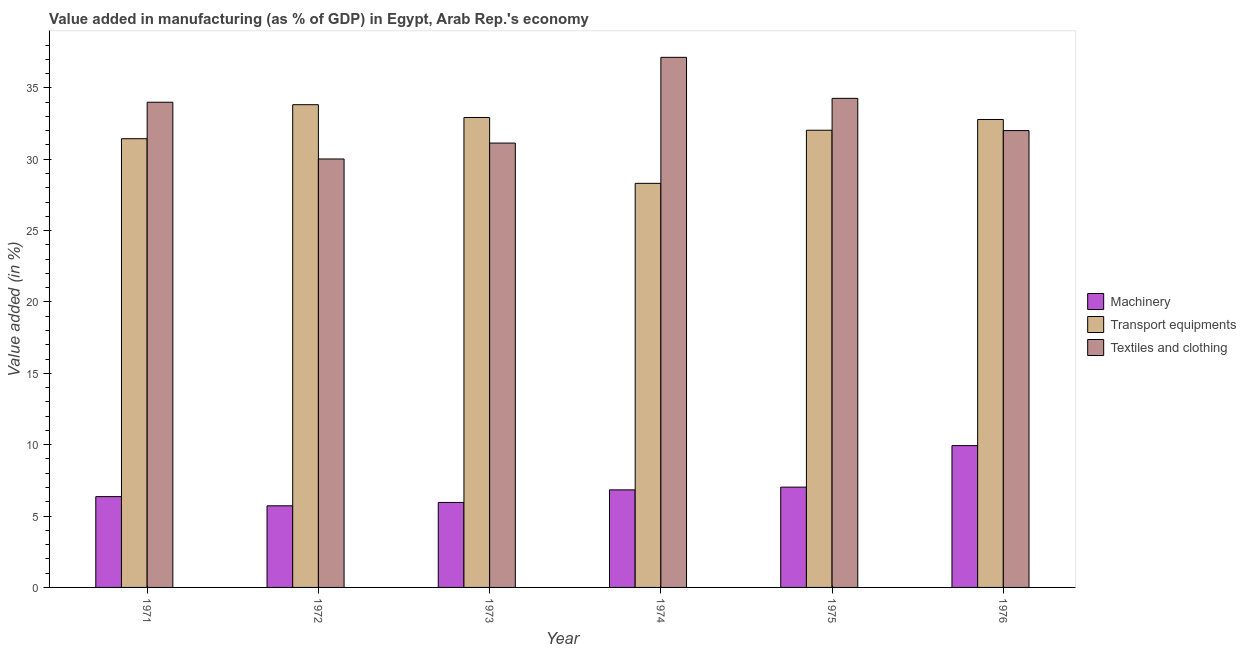How many groups of bars are there?
Offer a terse response. 6. Are the number of bars per tick equal to the number of legend labels?
Your answer should be very brief. Yes. How many bars are there on the 6th tick from the left?
Your answer should be very brief. 3. How many bars are there on the 5th tick from the right?
Provide a succinct answer. 3. What is the label of the 4th group of bars from the left?
Keep it short and to the point. 1974. In how many cases, is the number of bars for a given year not equal to the number of legend labels?
Keep it short and to the point. 0. What is the value added in manufacturing textile and clothing in 1976?
Your answer should be very brief. 32.01. Across all years, what is the maximum value added in manufacturing transport equipments?
Provide a short and direct response. 33.82. Across all years, what is the minimum value added in manufacturing machinery?
Your response must be concise. 5.72. In which year was the value added in manufacturing machinery maximum?
Your response must be concise. 1976. What is the total value added in manufacturing transport equipments in the graph?
Your response must be concise. 191.31. What is the difference between the value added in manufacturing transport equipments in 1971 and that in 1973?
Your answer should be very brief. -1.49. What is the difference between the value added in manufacturing textile and clothing in 1973 and the value added in manufacturing machinery in 1974?
Offer a very short reply. -6.01. What is the average value added in manufacturing textile and clothing per year?
Provide a short and direct response. 33.09. In the year 1974, what is the difference between the value added in manufacturing machinery and value added in manufacturing transport equipments?
Provide a succinct answer. 0. In how many years, is the value added in manufacturing machinery greater than 15 %?
Your answer should be compact. 0. What is the ratio of the value added in manufacturing machinery in 1971 to that in 1972?
Ensure brevity in your answer.  1.11. What is the difference between the highest and the second highest value added in manufacturing machinery?
Ensure brevity in your answer.  2.91. What is the difference between the highest and the lowest value added in manufacturing textile and clothing?
Your answer should be compact. 7.12. What does the 3rd bar from the left in 1971 represents?
Ensure brevity in your answer.  Textiles and clothing. What does the 2nd bar from the right in 1975 represents?
Offer a terse response. Transport equipments. Is it the case that in every year, the sum of the value added in manufacturing machinery and value added in manufacturing transport equipments is greater than the value added in manufacturing textile and clothing?
Your answer should be very brief. No. Are all the bars in the graph horizontal?
Provide a short and direct response. No. What is the difference between two consecutive major ticks on the Y-axis?
Provide a succinct answer. 5. Are the values on the major ticks of Y-axis written in scientific E-notation?
Your answer should be compact. No. Does the graph contain grids?
Your response must be concise. No. Where does the legend appear in the graph?
Offer a very short reply. Center right. How many legend labels are there?
Your answer should be very brief. 3. How are the legend labels stacked?
Give a very brief answer. Vertical. What is the title of the graph?
Your answer should be compact. Value added in manufacturing (as % of GDP) in Egypt, Arab Rep.'s economy. What is the label or title of the X-axis?
Your response must be concise. Year. What is the label or title of the Y-axis?
Offer a terse response. Value added (in %). What is the Value added (in %) in Machinery in 1971?
Provide a short and direct response. 6.36. What is the Value added (in %) in Transport equipments in 1971?
Ensure brevity in your answer.  31.44. What is the Value added (in %) in Textiles and clothing in 1971?
Provide a short and direct response. 33.99. What is the Value added (in %) in Machinery in 1972?
Your answer should be compact. 5.72. What is the Value added (in %) in Transport equipments in 1972?
Keep it short and to the point. 33.82. What is the Value added (in %) of Textiles and clothing in 1972?
Give a very brief answer. 30.02. What is the Value added (in %) of Machinery in 1973?
Keep it short and to the point. 5.95. What is the Value added (in %) in Transport equipments in 1973?
Offer a very short reply. 32.92. What is the Value added (in %) of Textiles and clothing in 1973?
Keep it short and to the point. 31.13. What is the Value added (in %) of Machinery in 1974?
Keep it short and to the point. 6.83. What is the Value added (in %) of Transport equipments in 1974?
Your answer should be very brief. 28.31. What is the Value added (in %) of Textiles and clothing in 1974?
Keep it short and to the point. 37.14. What is the Value added (in %) in Machinery in 1975?
Ensure brevity in your answer.  7.03. What is the Value added (in %) of Transport equipments in 1975?
Keep it short and to the point. 32.03. What is the Value added (in %) of Textiles and clothing in 1975?
Provide a succinct answer. 34.27. What is the Value added (in %) of Machinery in 1976?
Your response must be concise. 9.94. What is the Value added (in %) of Transport equipments in 1976?
Ensure brevity in your answer.  32.79. What is the Value added (in %) of Textiles and clothing in 1976?
Keep it short and to the point. 32.01. Across all years, what is the maximum Value added (in %) of Machinery?
Ensure brevity in your answer.  9.94. Across all years, what is the maximum Value added (in %) in Transport equipments?
Your answer should be very brief. 33.82. Across all years, what is the maximum Value added (in %) of Textiles and clothing?
Give a very brief answer. 37.14. Across all years, what is the minimum Value added (in %) of Machinery?
Your answer should be very brief. 5.72. Across all years, what is the minimum Value added (in %) in Transport equipments?
Provide a succinct answer. 28.31. Across all years, what is the minimum Value added (in %) in Textiles and clothing?
Ensure brevity in your answer.  30.02. What is the total Value added (in %) of Machinery in the graph?
Keep it short and to the point. 41.83. What is the total Value added (in %) of Transport equipments in the graph?
Offer a very short reply. 191.31. What is the total Value added (in %) of Textiles and clothing in the graph?
Provide a short and direct response. 198.56. What is the difference between the Value added (in %) in Machinery in 1971 and that in 1972?
Offer a very short reply. 0.64. What is the difference between the Value added (in %) of Transport equipments in 1971 and that in 1972?
Ensure brevity in your answer.  -2.38. What is the difference between the Value added (in %) in Textiles and clothing in 1971 and that in 1972?
Make the answer very short. 3.98. What is the difference between the Value added (in %) of Machinery in 1971 and that in 1973?
Your response must be concise. 0.41. What is the difference between the Value added (in %) in Transport equipments in 1971 and that in 1973?
Offer a terse response. -1.49. What is the difference between the Value added (in %) of Textiles and clothing in 1971 and that in 1973?
Offer a terse response. 2.86. What is the difference between the Value added (in %) in Machinery in 1971 and that in 1974?
Offer a terse response. -0.47. What is the difference between the Value added (in %) of Transport equipments in 1971 and that in 1974?
Offer a very short reply. 3.13. What is the difference between the Value added (in %) of Textiles and clothing in 1971 and that in 1974?
Your answer should be compact. -3.15. What is the difference between the Value added (in %) in Machinery in 1971 and that in 1975?
Offer a terse response. -0.66. What is the difference between the Value added (in %) in Transport equipments in 1971 and that in 1975?
Make the answer very short. -0.59. What is the difference between the Value added (in %) in Textiles and clothing in 1971 and that in 1975?
Provide a short and direct response. -0.27. What is the difference between the Value added (in %) of Machinery in 1971 and that in 1976?
Your answer should be very brief. -3.57. What is the difference between the Value added (in %) of Transport equipments in 1971 and that in 1976?
Your response must be concise. -1.35. What is the difference between the Value added (in %) of Textiles and clothing in 1971 and that in 1976?
Provide a short and direct response. 1.99. What is the difference between the Value added (in %) of Machinery in 1972 and that in 1973?
Offer a terse response. -0.24. What is the difference between the Value added (in %) in Transport equipments in 1972 and that in 1973?
Give a very brief answer. 0.9. What is the difference between the Value added (in %) in Textiles and clothing in 1972 and that in 1973?
Give a very brief answer. -1.11. What is the difference between the Value added (in %) of Machinery in 1972 and that in 1974?
Your answer should be compact. -1.12. What is the difference between the Value added (in %) of Transport equipments in 1972 and that in 1974?
Your answer should be very brief. 5.51. What is the difference between the Value added (in %) in Textiles and clothing in 1972 and that in 1974?
Keep it short and to the point. -7.12. What is the difference between the Value added (in %) in Machinery in 1972 and that in 1975?
Your answer should be very brief. -1.31. What is the difference between the Value added (in %) in Transport equipments in 1972 and that in 1975?
Provide a short and direct response. 1.79. What is the difference between the Value added (in %) in Textiles and clothing in 1972 and that in 1975?
Provide a succinct answer. -4.25. What is the difference between the Value added (in %) in Machinery in 1972 and that in 1976?
Give a very brief answer. -4.22. What is the difference between the Value added (in %) of Transport equipments in 1972 and that in 1976?
Ensure brevity in your answer.  1.04. What is the difference between the Value added (in %) of Textiles and clothing in 1972 and that in 1976?
Offer a very short reply. -1.99. What is the difference between the Value added (in %) of Machinery in 1973 and that in 1974?
Offer a very short reply. -0.88. What is the difference between the Value added (in %) of Transport equipments in 1973 and that in 1974?
Provide a short and direct response. 4.61. What is the difference between the Value added (in %) in Textiles and clothing in 1973 and that in 1974?
Offer a very short reply. -6.01. What is the difference between the Value added (in %) of Machinery in 1973 and that in 1975?
Keep it short and to the point. -1.07. What is the difference between the Value added (in %) in Transport equipments in 1973 and that in 1975?
Your response must be concise. 0.89. What is the difference between the Value added (in %) of Textiles and clothing in 1973 and that in 1975?
Keep it short and to the point. -3.13. What is the difference between the Value added (in %) in Machinery in 1973 and that in 1976?
Your answer should be very brief. -3.98. What is the difference between the Value added (in %) of Transport equipments in 1973 and that in 1976?
Keep it short and to the point. 0.14. What is the difference between the Value added (in %) of Textiles and clothing in 1973 and that in 1976?
Provide a succinct answer. -0.88. What is the difference between the Value added (in %) of Machinery in 1974 and that in 1975?
Your answer should be very brief. -0.19. What is the difference between the Value added (in %) in Transport equipments in 1974 and that in 1975?
Your response must be concise. -3.72. What is the difference between the Value added (in %) of Textiles and clothing in 1974 and that in 1975?
Your answer should be very brief. 2.87. What is the difference between the Value added (in %) in Machinery in 1974 and that in 1976?
Your response must be concise. -3.1. What is the difference between the Value added (in %) of Transport equipments in 1974 and that in 1976?
Provide a short and direct response. -4.47. What is the difference between the Value added (in %) of Textiles and clothing in 1974 and that in 1976?
Offer a terse response. 5.13. What is the difference between the Value added (in %) in Machinery in 1975 and that in 1976?
Provide a short and direct response. -2.91. What is the difference between the Value added (in %) of Transport equipments in 1975 and that in 1976?
Your answer should be compact. -0.75. What is the difference between the Value added (in %) in Textiles and clothing in 1975 and that in 1976?
Your answer should be very brief. 2.26. What is the difference between the Value added (in %) of Machinery in 1971 and the Value added (in %) of Transport equipments in 1972?
Give a very brief answer. -27.46. What is the difference between the Value added (in %) in Machinery in 1971 and the Value added (in %) in Textiles and clothing in 1972?
Provide a short and direct response. -23.66. What is the difference between the Value added (in %) in Transport equipments in 1971 and the Value added (in %) in Textiles and clothing in 1972?
Provide a short and direct response. 1.42. What is the difference between the Value added (in %) of Machinery in 1971 and the Value added (in %) of Transport equipments in 1973?
Make the answer very short. -26.56. What is the difference between the Value added (in %) in Machinery in 1971 and the Value added (in %) in Textiles and clothing in 1973?
Your answer should be very brief. -24.77. What is the difference between the Value added (in %) of Transport equipments in 1971 and the Value added (in %) of Textiles and clothing in 1973?
Provide a succinct answer. 0.31. What is the difference between the Value added (in %) of Machinery in 1971 and the Value added (in %) of Transport equipments in 1974?
Your answer should be compact. -21.95. What is the difference between the Value added (in %) in Machinery in 1971 and the Value added (in %) in Textiles and clothing in 1974?
Provide a succinct answer. -30.78. What is the difference between the Value added (in %) in Transport equipments in 1971 and the Value added (in %) in Textiles and clothing in 1974?
Give a very brief answer. -5.7. What is the difference between the Value added (in %) of Machinery in 1971 and the Value added (in %) of Transport equipments in 1975?
Provide a succinct answer. -25.67. What is the difference between the Value added (in %) of Machinery in 1971 and the Value added (in %) of Textiles and clothing in 1975?
Offer a very short reply. -27.9. What is the difference between the Value added (in %) in Transport equipments in 1971 and the Value added (in %) in Textiles and clothing in 1975?
Give a very brief answer. -2.83. What is the difference between the Value added (in %) of Machinery in 1971 and the Value added (in %) of Transport equipments in 1976?
Keep it short and to the point. -26.42. What is the difference between the Value added (in %) in Machinery in 1971 and the Value added (in %) in Textiles and clothing in 1976?
Keep it short and to the point. -25.65. What is the difference between the Value added (in %) of Transport equipments in 1971 and the Value added (in %) of Textiles and clothing in 1976?
Your answer should be compact. -0.57. What is the difference between the Value added (in %) of Machinery in 1972 and the Value added (in %) of Transport equipments in 1973?
Provide a short and direct response. -27.21. What is the difference between the Value added (in %) of Machinery in 1972 and the Value added (in %) of Textiles and clothing in 1973?
Your response must be concise. -25.41. What is the difference between the Value added (in %) in Transport equipments in 1972 and the Value added (in %) in Textiles and clothing in 1973?
Your answer should be compact. 2.69. What is the difference between the Value added (in %) of Machinery in 1972 and the Value added (in %) of Transport equipments in 1974?
Your response must be concise. -22.59. What is the difference between the Value added (in %) in Machinery in 1972 and the Value added (in %) in Textiles and clothing in 1974?
Your answer should be compact. -31.42. What is the difference between the Value added (in %) in Transport equipments in 1972 and the Value added (in %) in Textiles and clothing in 1974?
Ensure brevity in your answer.  -3.32. What is the difference between the Value added (in %) in Machinery in 1972 and the Value added (in %) in Transport equipments in 1975?
Offer a terse response. -26.31. What is the difference between the Value added (in %) of Machinery in 1972 and the Value added (in %) of Textiles and clothing in 1975?
Give a very brief answer. -28.55. What is the difference between the Value added (in %) of Transport equipments in 1972 and the Value added (in %) of Textiles and clothing in 1975?
Ensure brevity in your answer.  -0.44. What is the difference between the Value added (in %) of Machinery in 1972 and the Value added (in %) of Transport equipments in 1976?
Provide a succinct answer. -27.07. What is the difference between the Value added (in %) in Machinery in 1972 and the Value added (in %) in Textiles and clothing in 1976?
Your answer should be very brief. -26.29. What is the difference between the Value added (in %) of Transport equipments in 1972 and the Value added (in %) of Textiles and clothing in 1976?
Keep it short and to the point. 1.81. What is the difference between the Value added (in %) of Machinery in 1973 and the Value added (in %) of Transport equipments in 1974?
Offer a terse response. -22.36. What is the difference between the Value added (in %) of Machinery in 1973 and the Value added (in %) of Textiles and clothing in 1974?
Offer a terse response. -31.19. What is the difference between the Value added (in %) in Transport equipments in 1973 and the Value added (in %) in Textiles and clothing in 1974?
Provide a short and direct response. -4.22. What is the difference between the Value added (in %) of Machinery in 1973 and the Value added (in %) of Transport equipments in 1975?
Give a very brief answer. -26.08. What is the difference between the Value added (in %) of Machinery in 1973 and the Value added (in %) of Textiles and clothing in 1975?
Ensure brevity in your answer.  -28.31. What is the difference between the Value added (in %) in Transport equipments in 1973 and the Value added (in %) in Textiles and clothing in 1975?
Your answer should be compact. -1.34. What is the difference between the Value added (in %) of Machinery in 1973 and the Value added (in %) of Transport equipments in 1976?
Your answer should be compact. -26.83. What is the difference between the Value added (in %) in Machinery in 1973 and the Value added (in %) in Textiles and clothing in 1976?
Your response must be concise. -26.05. What is the difference between the Value added (in %) of Transport equipments in 1973 and the Value added (in %) of Textiles and clothing in 1976?
Provide a succinct answer. 0.92. What is the difference between the Value added (in %) of Machinery in 1974 and the Value added (in %) of Transport equipments in 1975?
Make the answer very short. -25.2. What is the difference between the Value added (in %) in Machinery in 1974 and the Value added (in %) in Textiles and clothing in 1975?
Provide a succinct answer. -27.43. What is the difference between the Value added (in %) in Transport equipments in 1974 and the Value added (in %) in Textiles and clothing in 1975?
Your answer should be very brief. -5.95. What is the difference between the Value added (in %) in Machinery in 1974 and the Value added (in %) in Transport equipments in 1976?
Offer a very short reply. -25.95. What is the difference between the Value added (in %) of Machinery in 1974 and the Value added (in %) of Textiles and clothing in 1976?
Provide a succinct answer. -25.17. What is the difference between the Value added (in %) in Transport equipments in 1974 and the Value added (in %) in Textiles and clothing in 1976?
Keep it short and to the point. -3.7. What is the difference between the Value added (in %) in Machinery in 1975 and the Value added (in %) in Transport equipments in 1976?
Offer a very short reply. -25.76. What is the difference between the Value added (in %) of Machinery in 1975 and the Value added (in %) of Textiles and clothing in 1976?
Ensure brevity in your answer.  -24.98. What is the difference between the Value added (in %) of Transport equipments in 1975 and the Value added (in %) of Textiles and clothing in 1976?
Offer a very short reply. 0.02. What is the average Value added (in %) in Machinery per year?
Offer a very short reply. 6.97. What is the average Value added (in %) in Transport equipments per year?
Make the answer very short. 31.89. What is the average Value added (in %) of Textiles and clothing per year?
Your response must be concise. 33.09. In the year 1971, what is the difference between the Value added (in %) of Machinery and Value added (in %) of Transport equipments?
Your answer should be compact. -25.08. In the year 1971, what is the difference between the Value added (in %) of Machinery and Value added (in %) of Textiles and clothing?
Keep it short and to the point. -27.63. In the year 1971, what is the difference between the Value added (in %) in Transport equipments and Value added (in %) in Textiles and clothing?
Give a very brief answer. -2.56. In the year 1972, what is the difference between the Value added (in %) of Machinery and Value added (in %) of Transport equipments?
Ensure brevity in your answer.  -28.1. In the year 1972, what is the difference between the Value added (in %) of Machinery and Value added (in %) of Textiles and clothing?
Keep it short and to the point. -24.3. In the year 1972, what is the difference between the Value added (in %) of Transport equipments and Value added (in %) of Textiles and clothing?
Make the answer very short. 3.8. In the year 1973, what is the difference between the Value added (in %) in Machinery and Value added (in %) in Transport equipments?
Provide a short and direct response. -26.97. In the year 1973, what is the difference between the Value added (in %) of Machinery and Value added (in %) of Textiles and clothing?
Your response must be concise. -25.18. In the year 1973, what is the difference between the Value added (in %) in Transport equipments and Value added (in %) in Textiles and clothing?
Offer a terse response. 1.79. In the year 1974, what is the difference between the Value added (in %) in Machinery and Value added (in %) in Transport equipments?
Keep it short and to the point. -21.48. In the year 1974, what is the difference between the Value added (in %) of Machinery and Value added (in %) of Textiles and clothing?
Make the answer very short. -30.31. In the year 1974, what is the difference between the Value added (in %) in Transport equipments and Value added (in %) in Textiles and clothing?
Offer a very short reply. -8.83. In the year 1975, what is the difference between the Value added (in %) of Machinery and Value added (in %) of Transport equipments?
Your answer should be compact. -25. In the year 1975, what is the difference between the Value added (in %) of Machinery and Value added (in %) of Textiles and clothing?
Make the answer very short. -27.24. In the year 1975, what is the difference between the Value added (in %) in Transport equipments and Value added (in %) in Textiles and clothing?
Ensure brevity in your answer.  -2.23. In the year 1976, what is the difference between the Value added (in %) in Machinery and Value added (in %) in Transport equipments?
Offer a terse response. -22.85. In the year 1976, what is the difference between the Value added (in %) of Machinery and Value added (in %) of Textiles and clothing?
Keep it short and to the point. -22.07. In the year 1976, what is the difference between the Value added (in %) in Transport equipments and Value added (in %) in Textiles and clothing?
Provide a succinct answer. 0.78. What is the ratio of the Value added (in %) in Machinery in 1971 to that in 1972?
Keep it short and to the point. 1.11. What is the ratio of the Value added (in %) in Transport equipments in 1971 to that in 1972?
Your answer should be very brief. 0.93. What is the ratio of the Value added (in %) in Textiles and clothing in 1971 to that in 1972?
Make the answer very short. 1.13. What is the ratio of the Value added (in %) of Machinery in 1971 to that in 1973?
Make the answer very short. 1.07. What is the ratio of the Value added (in %) in Transport equipments in 1971 to that in 1973?
Your answer should be very brief. 0.95. What is the ratio of the Value added (in %) of Textiles and clothing in 1971 to that in 1973?
Offer a terse response. 1.09. What is the ratio of the Value added (in %) in Machinery in 1971 to that in 1974?
Offer a very short reply. 0.93. What is the ratio of the Value added (in %) of Transport equipments in 1971 to that in 1974?
Your response must be concise. 1.11. What is the ratio of the Value added (in %) of Textiles and clothing in 1971 to that in 1974?
Offer a very short reply. 0.92. What is the ratio of the Value added (in %) of Machinery in 1971 to that in 1975?
Offer a terse response. 0.91. What is the ratio of the Value added (in %) of Transport equipments in 1971 to that in 1975?
Ensure brevity in your answer.  0.98. What is the ratio of the Value added (in %) in Textiles and clothing in 1971 to that in 1975?
Your response must be concise. 0.99. What is the ratio of the Value added (in %) of Machinery in 1971 to that in 1976?
Provide a succinct answer. 0.64. What is the ratio of the Value added (in %) in Transport equipments in 1971 to that in 1976?
Your answer should be compact. 0.96. What is the ratio of the Value added (in %) of Textiles and clothing in 1971 to that in 1976?
Offer a terse response. 1.06. What is the ratio of the Value added (in %) of Machinery in 1972 to that in 1973?
Offer a terse response. 0.96. What is the ratio of the Value added (in %) of Transport equipments in 1972 to that in 1973?
Make the answer very short. 1.03. What is the ratio of the Value added (in %) of Textiles and clothing in 1972 to that in 1973?
Keep it short and to the point. 0.96. What is the ratio of the Value added (in %) of Machinery in 1972 to that in 1974?
Ensure brevity in your answer.  0.84. What is the ratio of the Value added (in %) in Transport equipments in 1972 to that in 1974?
Provide a succinct answer. 1.19. What is the ratio of the Value added (in %) in Textiles and clothing in 1972 to that in 1974?
Give a very brief answer. 0.81. What is the ratio of the Value added (in %) of Machinery in 1972 to that in 1975?
Your answer should be compact. 0.81. What is the ratio of the Value added (in %) of Transport equipments in 1972 to that in 1975?
Your answer should be compact. 1.06. What is the ratio of the Value added (in %) of Textiles and clothing in 1972 to that in 1975?
Your response must be concise. 0.88. What is the ratio of the Value added (in %) of Machinery in 1972 to that in 1976?
Your answer should be compact. 0.58. What is the ratio of the Value added (in %) in Transport equipments in 1972 to that in 1976?
Provide a short and direct response. 1.03. What is the ratio of the Value added (in %) of Textiles and clothing in 1972 to that in 1976?
Your answer should be very brief. 0.94. What is the ratio of the Value added (in %) of Machinery in 1973 to that in 1974?
Provide a succinct answer. 0.87. What is the ratio of the Value added (in %) in Transport equipments in 1973 to that in 1974?
Make the answer very short. 1.16. What is the ratio of the Value added (in %) in Textiles and clothing in 1973 to that in 1974?
Offer a very short reply. 0.84. What is the ratio of the Value added (in %) of Machinery in 1973 to that in 1975?
Your answer should be compact. 0.85. What is the ratio of the Value added (in %) in Transport equipments in 1973 to that in 1975?
Provide a succinct answer. 1.03. What is the ratio of the Value added (in %) in Textiles and clothing in 1973 to that in 1975?
Provide a succinct answer. 0.91. What is the ratio of the Value added (in %) in Machinery in 1973 to that in 1976?
Your answer should be very brief. 0.6. What is the ratio of the Value added (in %) of Transport equipments in 1973 to that in 1976?
Provide a short and direct response. 1. What is the ratio of the Value added (in %) of Textiles and clothing in 1973 to that in 1976?
Your response must be concise. 0.97. What is the ratio of the Value added (in %) of Machinery in 1974 to that in 1975?
Your response must be concise. 0.97. What is the ratio of the Value added (in %) in Transport equipments in 1974 to that in 1975?
Make the answer very short. 0.88. What is the ratio of the Value added (in %) in Textiles and clothing in 1974 to that in 1975?
Offer a terse response. 1.08. What is the ratio of the Value added (in %) in Machinery in 1974 to that in 1976?
Your response must be concise. 0.69. What is the ratio of the Value added (in %) in Transport equipments in 1974 to that in 1976?
Make the answer very short. 0.86. What is the ratio of the Value added (in %) in Textiles and clothing in 1974 to that in 1976?
Ensure brevity in your answer.  1.16. What is the ratio of the Value added (in %) in Machinery in 1975 to that in 1976?
Provide a succinct answer. 0.71. What is the ratio of the Value added (in %) of Textiles and clothing in 1975 to that in 1976?
Make the answer very short. 1.07. What is the difference between the highest and the second highest Value added (in %) of Machinery?
Your response must be concise. 2.91. What is the difference between the highest and the second highest Value added (in %) of Transport equipments?
Keep it short and to the point. 0.9. What is the difference between the highest and the second highest Value added (in %) of Textiles and clothing?
Ensure brevity in your answer.  2.87. What is the difference between the highest and the lowest Value added (in %) of Machinery?
Provide a succinct answer. 4.22. What is the difference between the highest and the lowest Value added (in %) of Transport equipments?
Offer a very short reply. 5.51. What is the difference between the highest and the lowest Value added (in %) of Textiles and clothing?
Your answer should be compact. 7.12. 